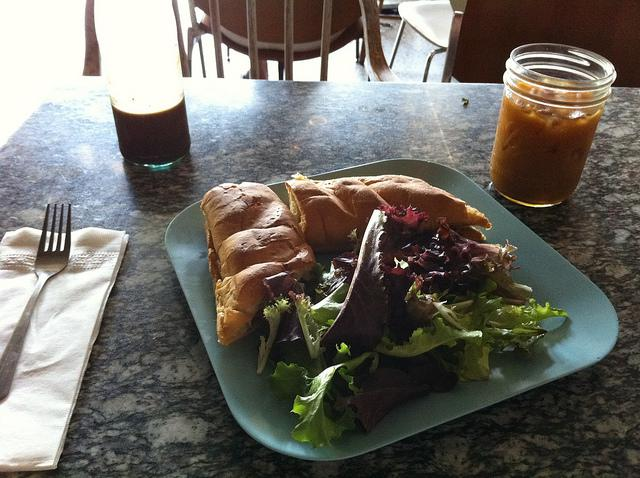What type of drink in in the jar? coffee 